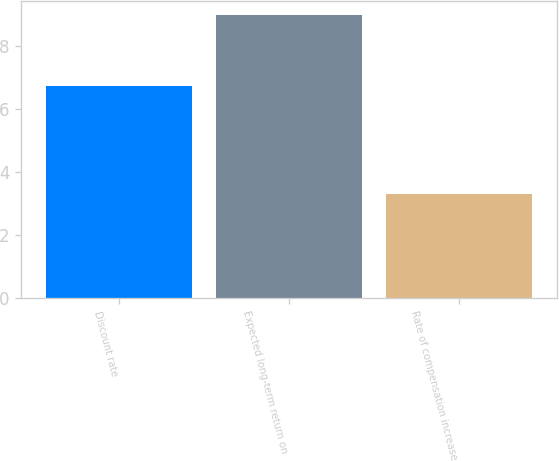<chart> <loc_0><loc_0><loc_500><loc_500><bar_chart><fcel>Discount rate<fcel>Expected long-term return on<fcel>Rate of compensation increase<nl><fcel>6.75<fcel>9<fcel>3.29<nl></chart> 